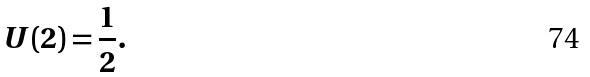Convert formula to latex. <formula><loc_0><loc_0><loc_500><loc_500>U ( 2 ) = { \frac { 1 } { 2 } } .</formula> 